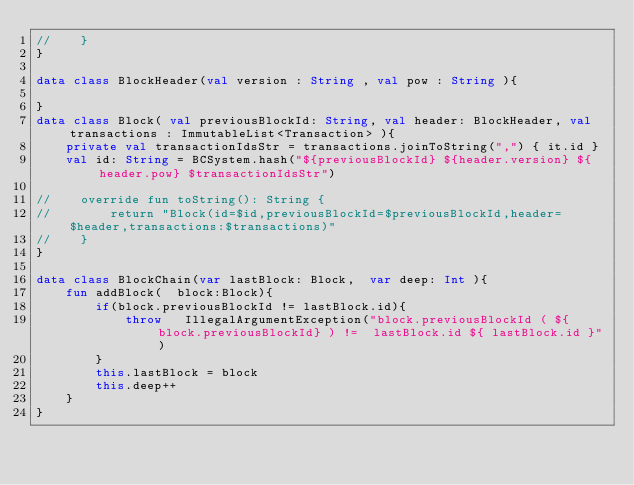<code> <loc_0><loc_0><loc_500><loc_500><_Kotlin_>//    }
}

data class BlockHeader(val version : String , val pow : String ){

}
data class Block( val previousBlockId: String, val header: BlockHeader, val transactions : ImmutableList<Transaction> ){
    private val transactionIdsStr = transactions.joinToString(",") { it.id }
    val id: String = BCSystem.hash("${previousBlockId} ${header.version} ${header.pow} $transactionIdsStr")

//    override fun toString(): String {
//        return "Block(id=$id,previousBlockId=$previousBlockId,header=$header,transactions:$transactions)"
//    }
}

data class BlockChain(var lastBlock: Block,  var deep: Int ){
    fun addBlock(  block:Block){
        if(block.previousBlockId != lastBlock.id){
            throw   IllegalArgumentException("block.previousBlockId ( ${ block.previousBlockId} ) !=  lastBlock.id ${ lastBlock.id }")
        }
        this.lastBlock = block
        this.deep++
    }
}



</code> 